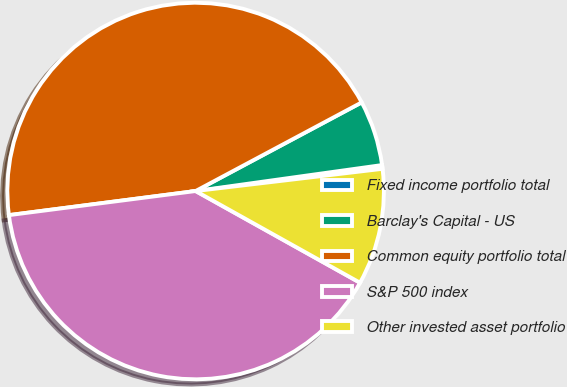Convert chart. <chart><loc_0><loc_0><loc_500><loc_500><pie_chart><fcel>Fixed income portfolio total<fcel>Barclay's Capital - US<fcel>Common equity portfolio total<fcel>S&P 500 index<fcel>Other invested asset portfolio<nl><fcel>0.32%<fcel>5.6%<fcel>44.24%<fcel>39.86%<fcel>9.98%<nl></chart> 